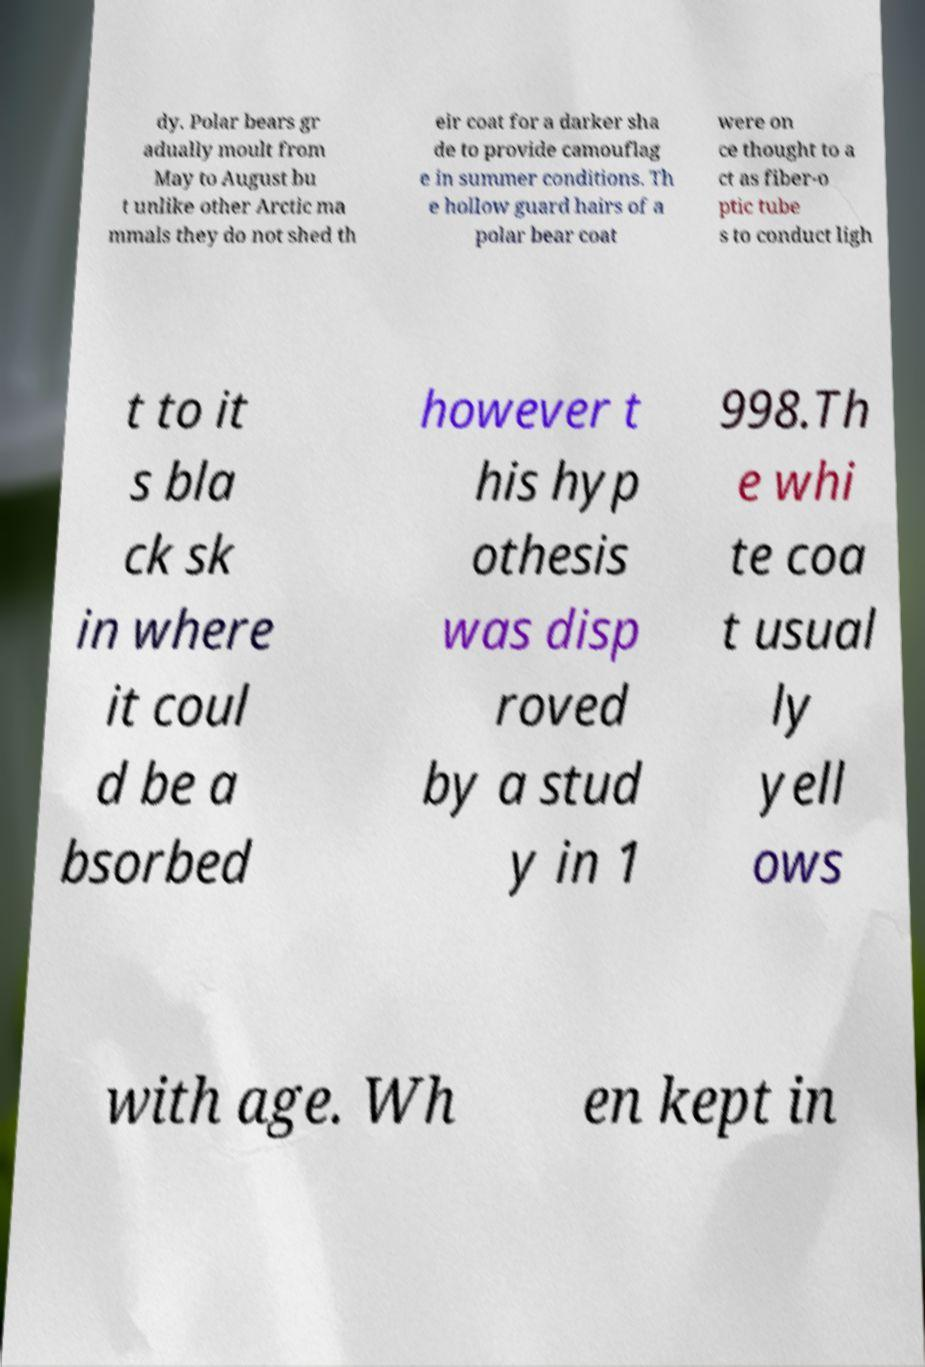Please identify and transcribe the text found in this image. dy. Polar bears gr adually moult from May to August bu t unlike other Arctic ma mmals they do not shed th eir coat for a darker sha de to provide camouflag e in summer conditions. Th e hollow guard hairs of a polar bear coat were on ce thought to a ct as fiber-o ptic tube s to conduct ligh t to it s bla ck sk in where it coul d be a bsorbed however t his hyp othesis was disp roved by a stud y in 1 998.Th e whi te coa t usual ly yell ows with age. Wh en kept in 